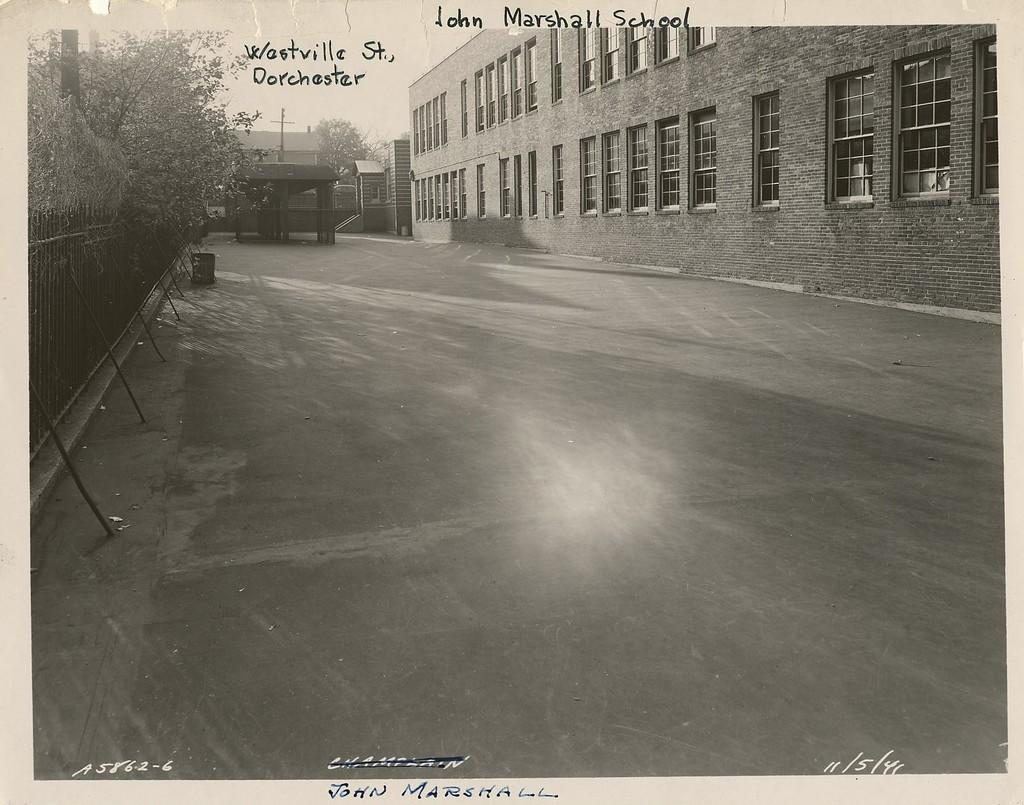What type of pathway is present in the image? There is a road in the image. What natural elements can be seen in the image? There are trees in the image. What man-made structures are present in the image? There is a fence, a pole, and buildings with windows in the image. Are there any architectural features in the image? Yes, there are steps in the image. Is there any text visible in the image? Yes, there is some text visible in the image. Can you tell me when the birth of the first person in the image occurred? There is no information about any person's birth in the image, as it primarily features a road, trees, a fence, a pole, buildings, steps, and text. What is the slope of the road in the image? The facts provided do not mention the slope of the road, so it cannot be determined from the image. 